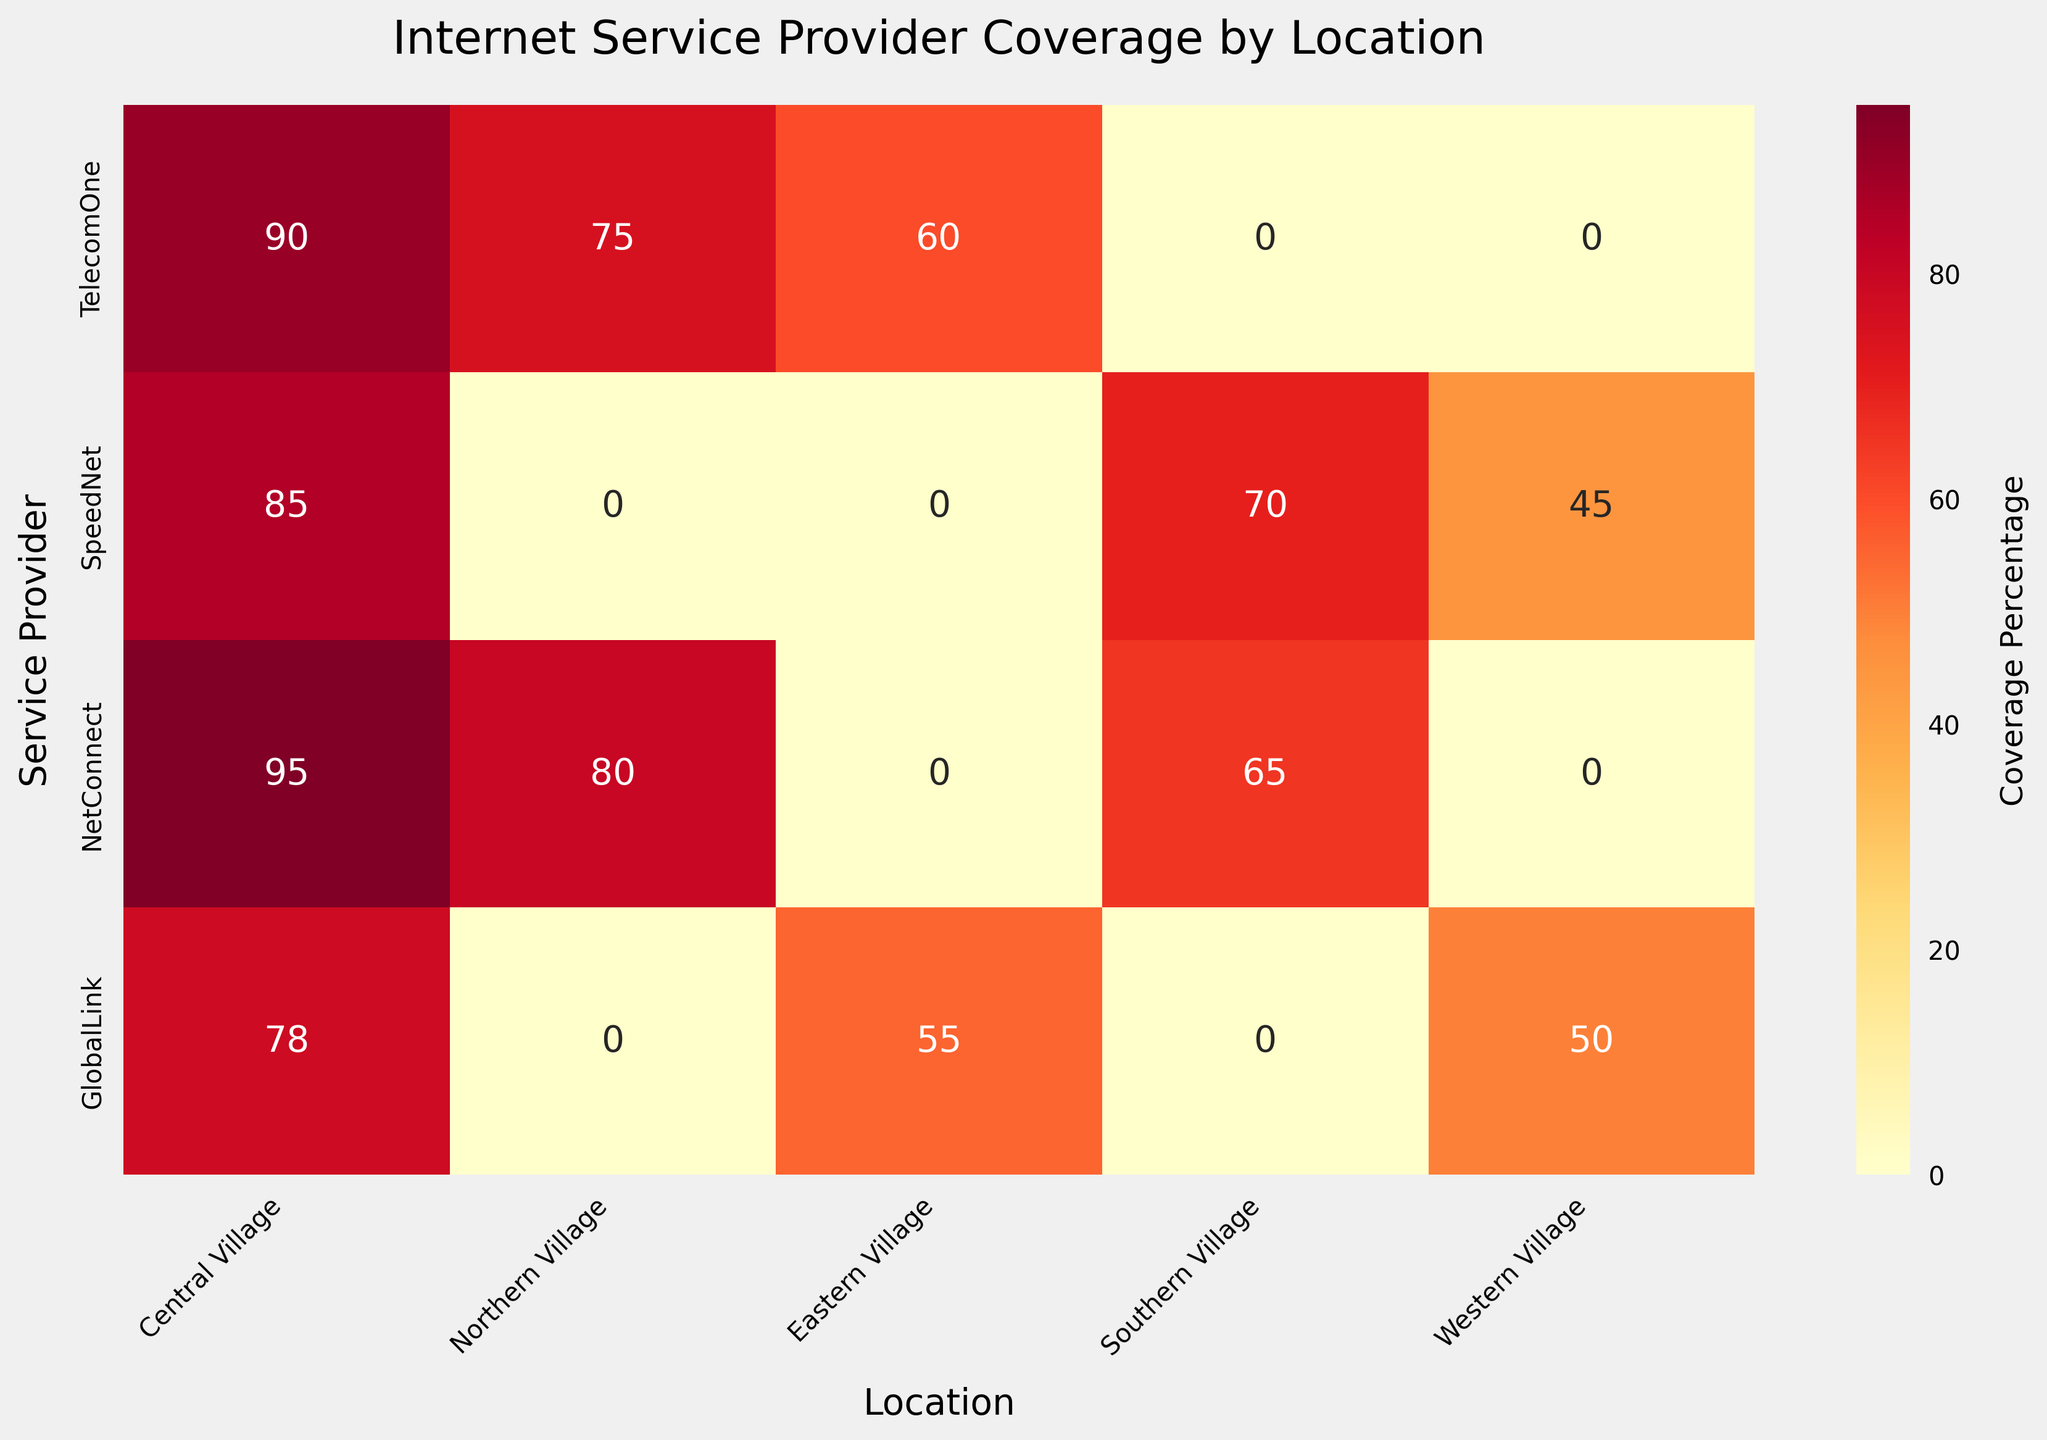What is the coverage percentage of TelecomOne in the Central Village? Locate the intersection of TelecomOne (row) and Central Village (column) on the heatmap. The annotated value is 90.
Answer: 90 Which service provider has the highest coverage in the Western Village? Compare the annotated values in the Western Village column for each provider. NetConnect has the highest coverage of 50 in Western Village.
Answer: NetConnect What is the average coverage percentage for SpeedNet across all villages? Locate SpeedNet's row and add the coverage percentages: (85 + 70 + 45). Divide by the number of locations (3). The calculation is (85 + 70 + 45) / 3 = 66.67.
Answer: 66.67 How many service providers have coverage in the Northern Village? Count the number of annotated values in the Northern Village column. Four providers have values: TelecomOne, NetConnect, and SpeedNet.
Answer: 3 Which village has the lowest coverage from GlobalLink? Locate GlobalLink's row and compare the values across columns. The lowest coverage is 50 in Western Village.
Answer: Western Village What is the total coverage percentage of NetConnect across all locations? Sum the coverage percentages of NetConnect in each location: (95 + 80 + 65). The calculation is 95 + 80 + 65 = 240.
Answer: 240 Is there any village where all providers have coverage above 60%? Check each village column to see if all annotated values are above 60%. Only Central Village has all providers with coverage percentages above 60%.
Answer: Yes Which service provider has the most varied coverage across different villages? Calculate the range (max-min) of coverage for each provider. TelecomOne: (90-60=30); SpeedNet: (85-45=40); NetConnect: (95-65=30); GlobalLink: (78-50=28). SpeedNet has the highest range.
Answer: SpeedNet 